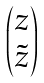<formula> <loc_0><loc_0><loc_500><loc_500>\begin{pmatrix} z \\ \tilde { z } \end{pmatrix}</formula> 